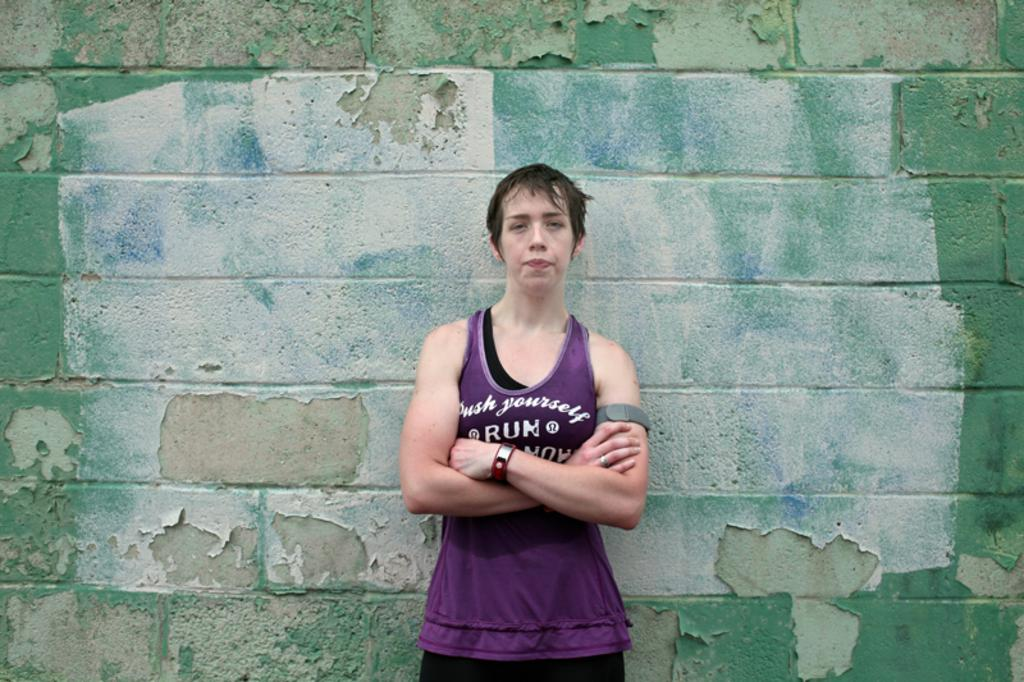What is the main subject of the image? There is a person standing in the center of the image. What can be seen in the background of the image? There is a wall in the background of the image. Where is the goldfish swimming in the image? There is no goldfish present in the image. 